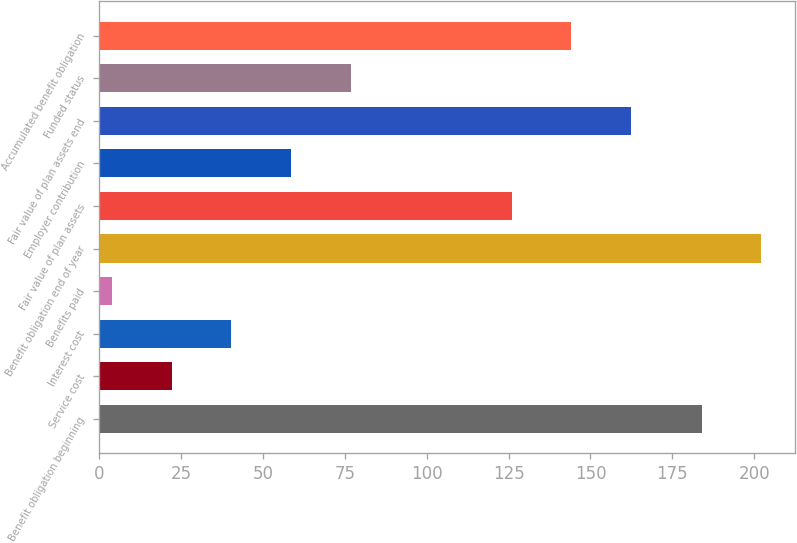Convert chart. <chart><loc_0><loc_0><loc_500><loc_500><bar_chart><fcel>Benefit obligation beginning<fcel>Service cost<fcel>Interest cost<fcel>Benefits paid<fcel>Benefit obligation end of year<fcel>Fair value of plan assets<fcel>Employer contribution<fcel>Fair value of plan assets end<fcel>Funded status<fcel>Accumulated benefit obligation<nl><fcel>184<fcel>22.2<fcel>40.4<fcel>4<fcel>202.2<fcel>126<fcel>58.6<fcel>162.4<fcel>76.8<fcel>144.2<nl></chart> 